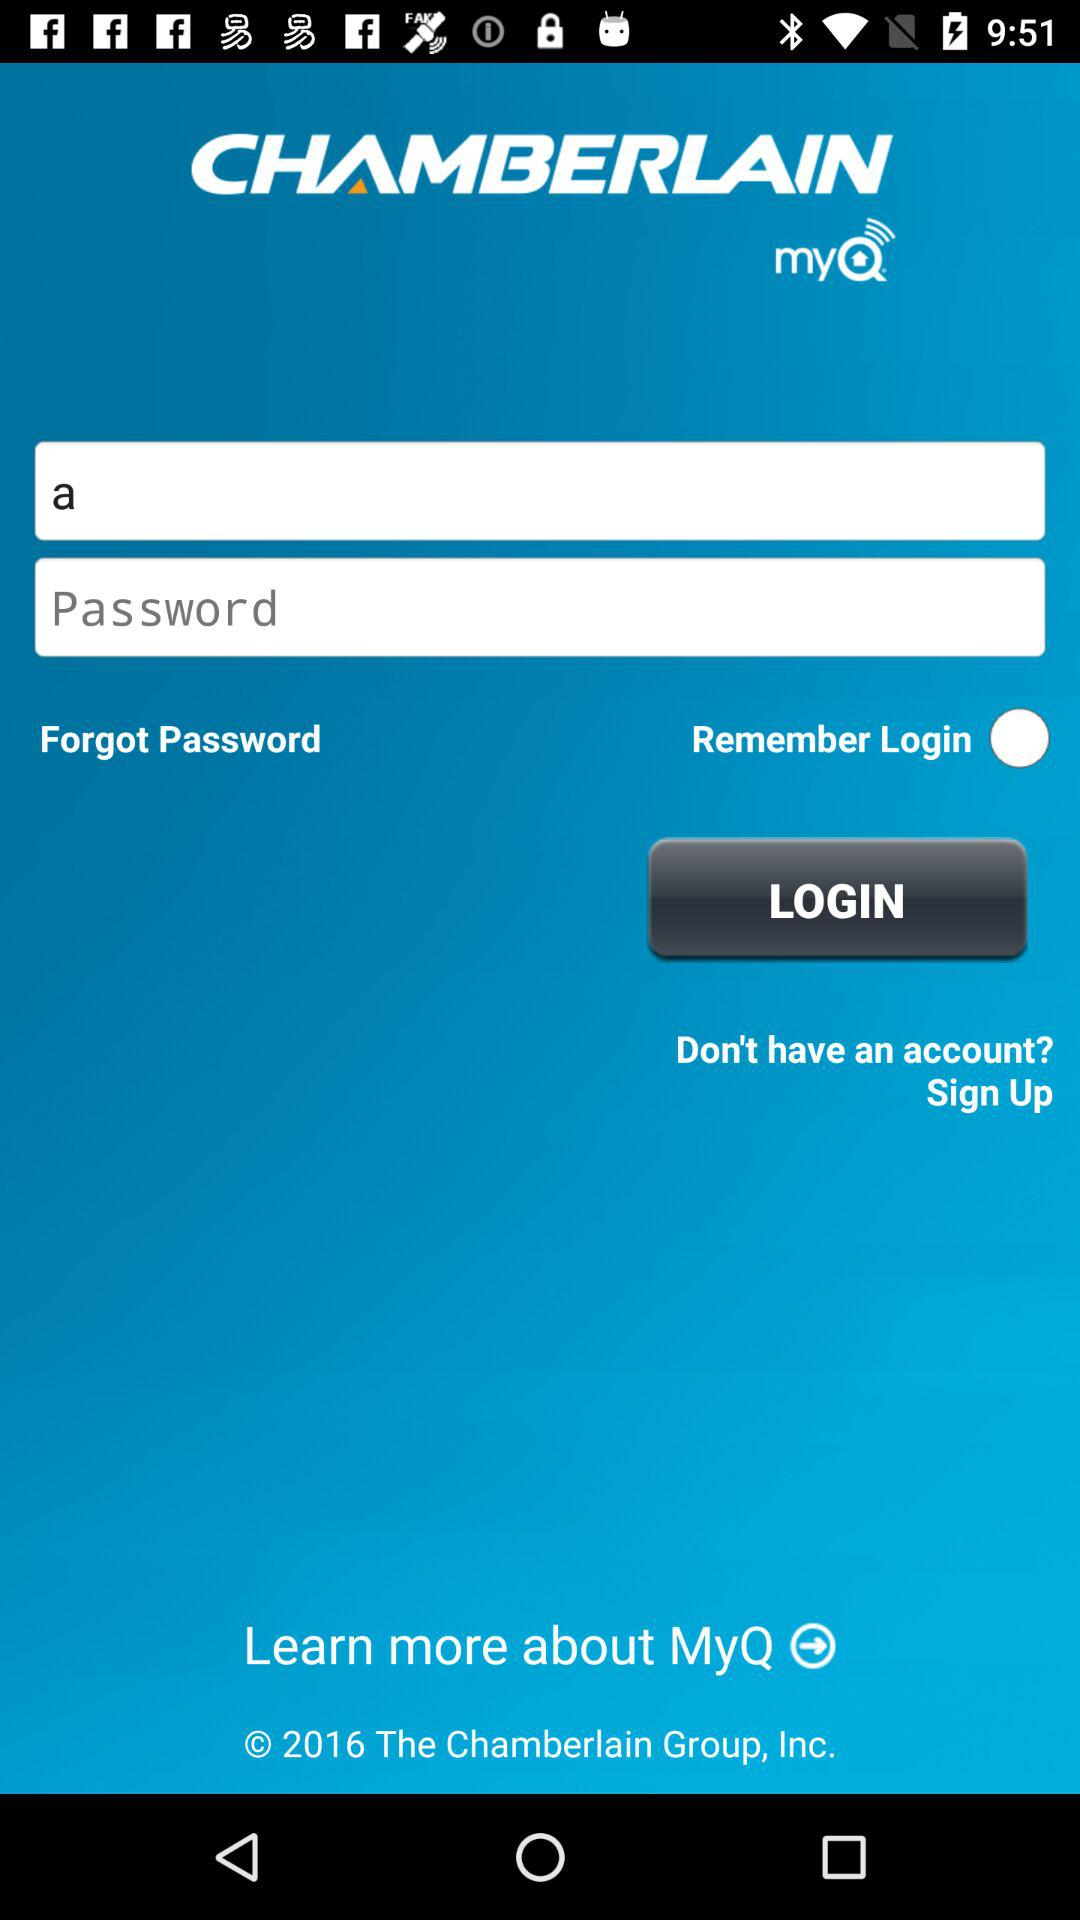What's the status of "Remember login"? The status is "off". 